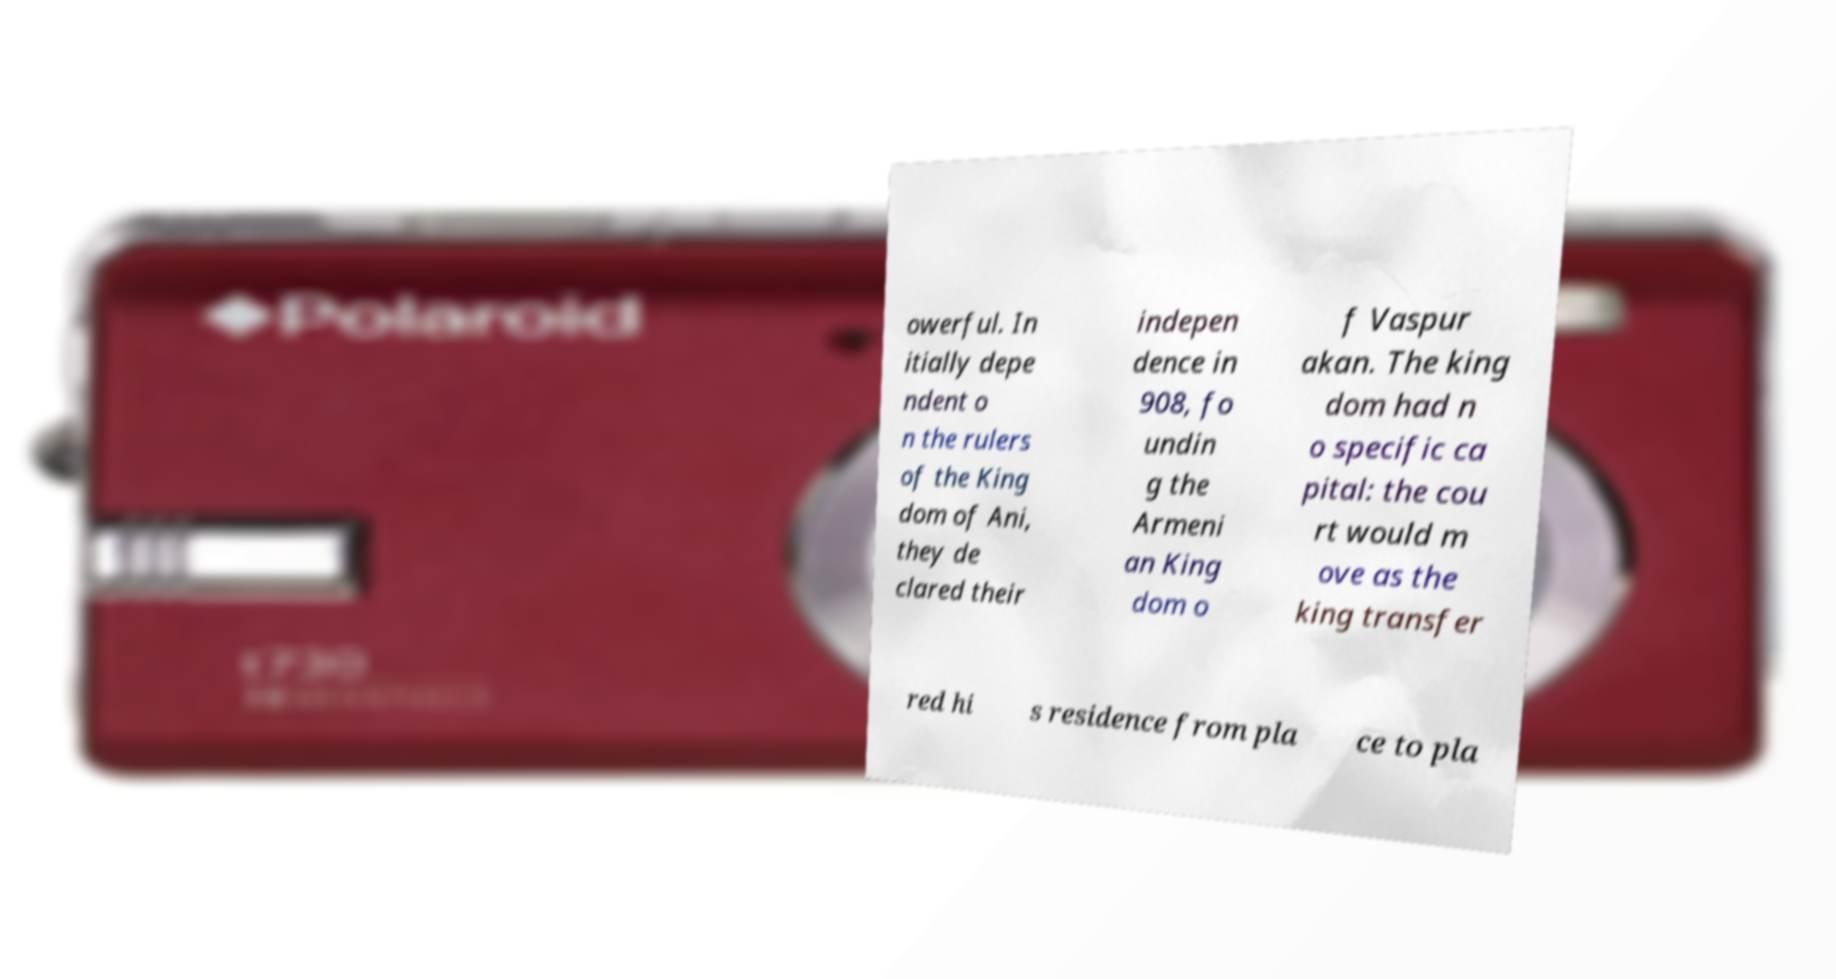Please identify and transcribe the text found in this image. owerful. In itially depe ndent o n the rulers of the King dom of Ani, they de clared their indepen dence in 908, fo undin g the Armeni an King dom o f Vaspur akan. The king dom had n o specific ca pital: the cou rt would m ove as the king transfer red hi s residence from pla ce to pla 